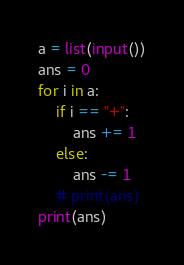Convert code to text. <code><loc_0><loc_0><loc_500><loc_500><_Python_>a = list(input())
ans = 0
for i in a:
    if i == "+":
        ans += 1
    else:
        ans -= 1
    # print(ans)
print(ans)</code> 